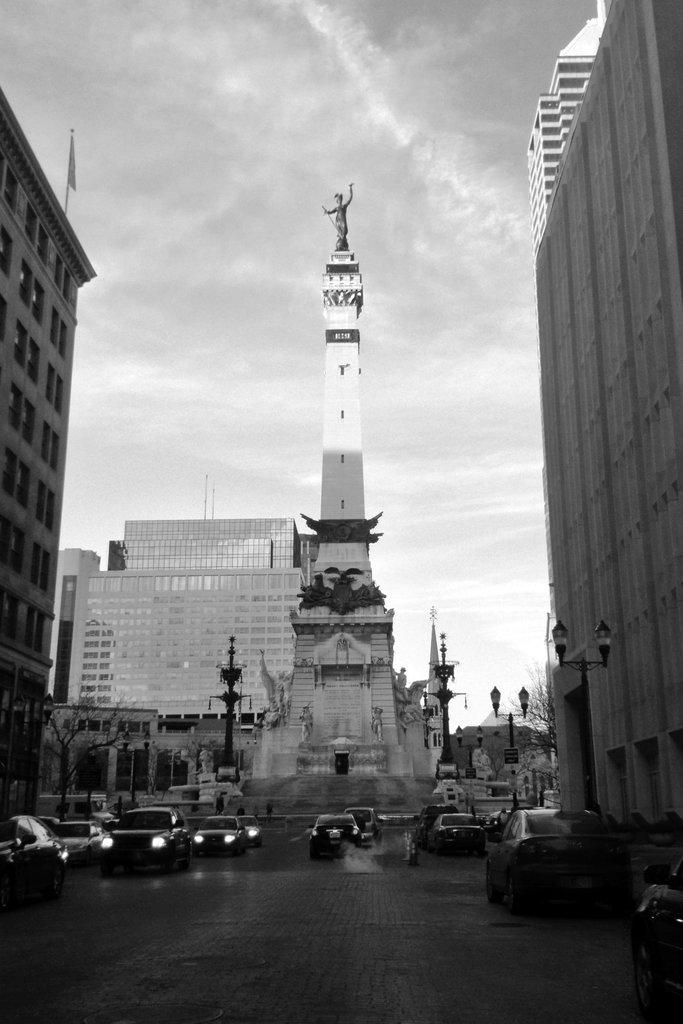What can be seen on the road in the image? There are vehicles on the road in the image. What type of structures are present in the image? There are buildings in the image. What additional features can be found in the image? There are statues, trees, poles, and lights in the image. What is visible in the background of the image? The sky is visible in the background of the image. Can you tell me how many pears are on the statues in the image? There are no pears present in the image; it features statues, but no pears are depicted on them. What type of cheese is being used to illuminate the lights in the image? There is no cheese present in the image, and the lights are not illuminated by cheese. 